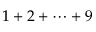Convert formula to latex. <formula><loc_0><loc_0><loc_500><loc_500>1 + 2 + \dots b + 9</formula> 